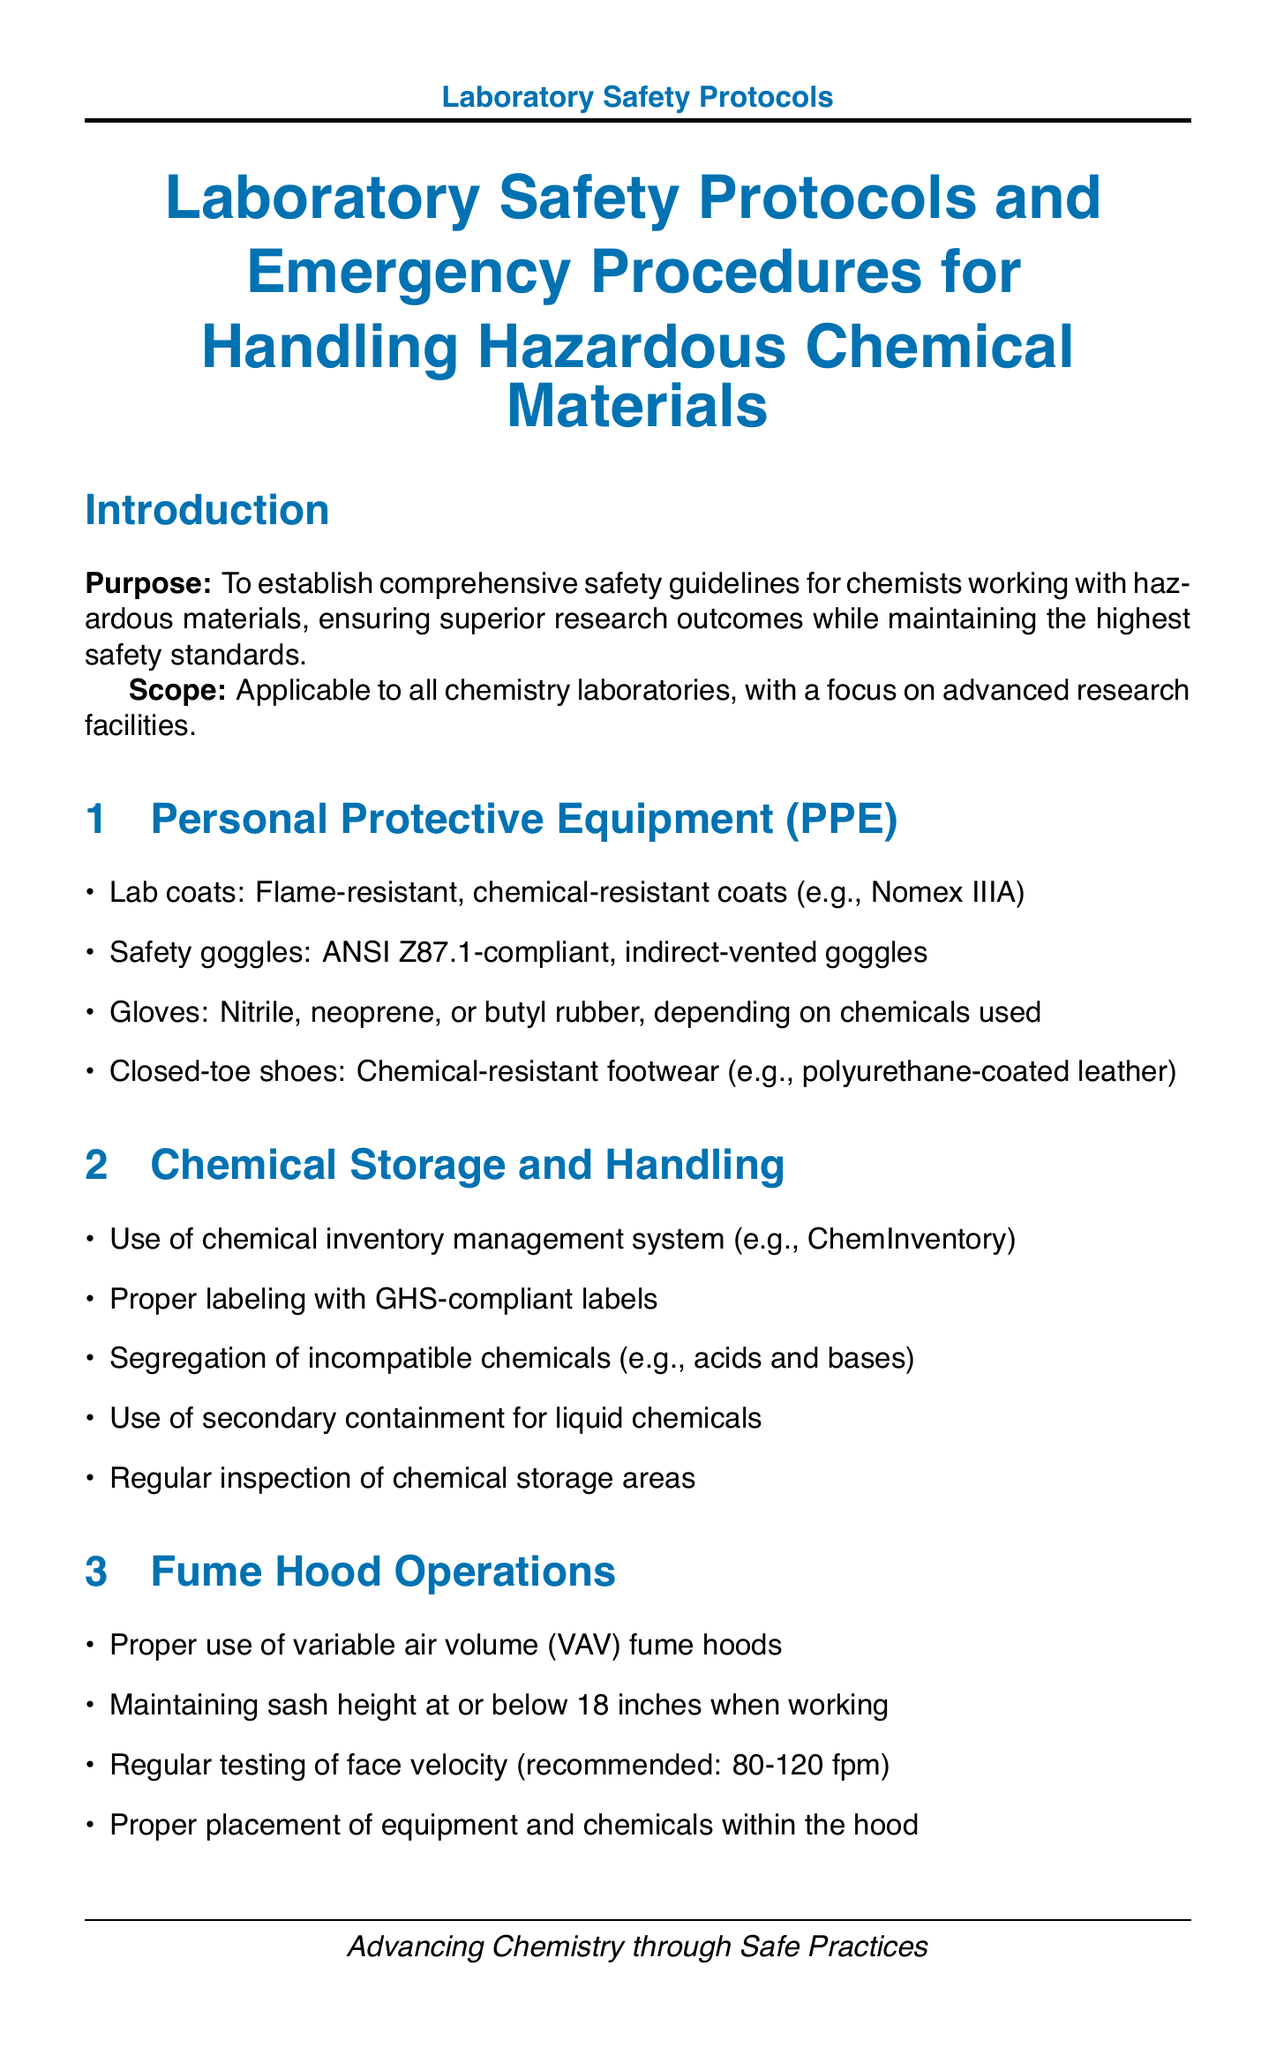What is the purpose of the document? The purpose is outlined in the introduction, establishing safety guidelines for chemists working with hazardous materials.
Answer: To establish comprehensive safety guidelines What type of gloves should be used? The document specifies the types of gloves depending on the chemicals used in the Personal Protective Equipment section.
Answer: Nitrile, neoprene, or butyl rubber What is the recommended face velocity for fume hoods? The recommended face velocity is mentioned in the Fume Hood Operations section.
Answer: 80-120 fpm What system is recommended for chemical inventory management? The document points to a specific system in the Chemical Storage and Handling section.
Answer: ChemInventory What should be used for hydrofluoric acid exposure? This is mentioned in the First Aid section regarding treatments for specific chemical exposures.
Answer: Calcium gluconate gel How often should safety drills be conducted? The frequency of safety drills is stated in the Training and Certifications section.
Answer: Quarterly Which document should be used for high-risk procedures? The document indicates a specific assessment form in the Risk Assessment section.
Answer: Job Safety Analysis (JSA) What equipment should be used for chemical spill response? The document lists specific kits in the Emergency Procedures section for handling spills.
Answer: New Pig Spill Kit What is the main focus of the conclusion? The conclusion summarizes the overall aim of the safety protocols as outlined in the closing section.
Answer: Ensuring a safe work environment 